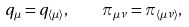Convert formula to latex. <formula><loc_0><loc_0><loc_500><loc_500>q _ { \mu } = q _ { \langle \mu \rangle } , \quad \pi _ { \mu \nu } = \pi _ { \langle \mu \nu \rangle } ,</formula> 